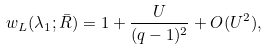<formula> <loc_0><loc_0><loc_500><loc_500>w _ { L } ( \lambda _ { 1 } ; \bar { R } ) = 1 + \frac { U } { ( q - 1 ) ^ { 2 } } + O ( U ^ { 2 } ) ,</formula> 